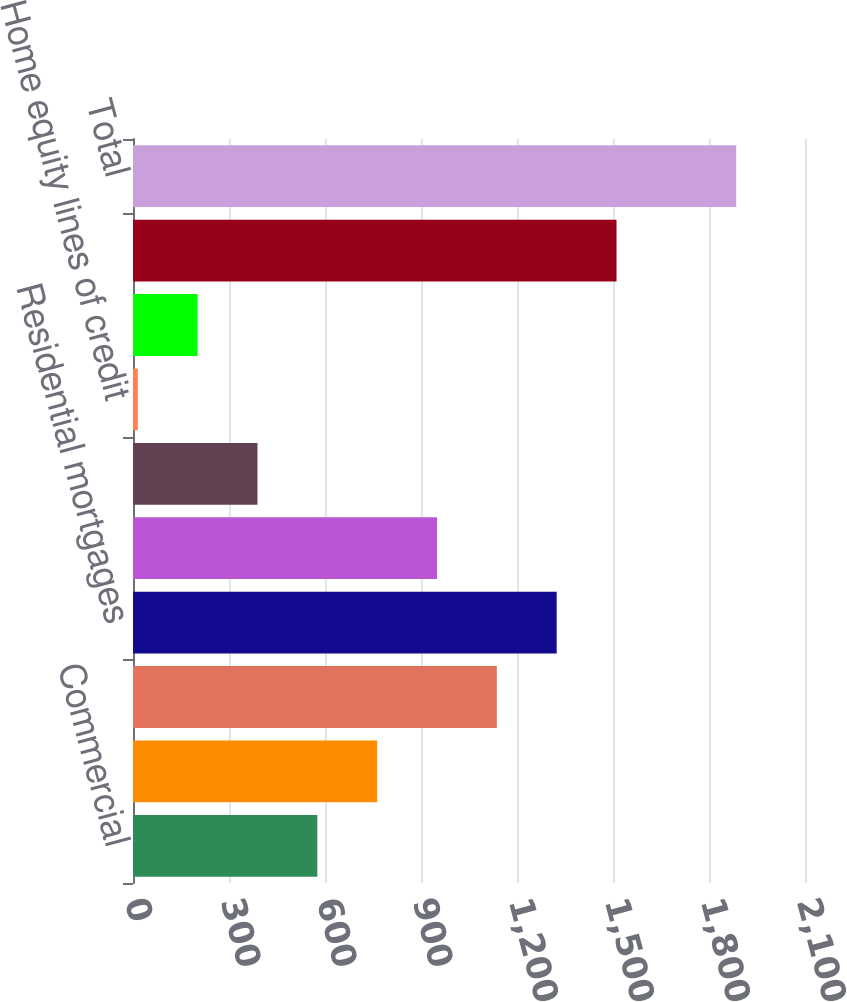Convert chart to OTSL. <chart><loc_0><loc_0><loc_500><loc_500><bar_chart><fcel>Commercial<fcel>Commercial real estate<fcel>Total commercial<fcel>Residential mortgages<fcel>Home equity loans<fcel>Home equity loans serviced by<fcel>Home equity lines of credit<fcel>Other retail<fcel>Total retail<fcel>Total<nl><fcel>576<fcel>763<fcel>1137<fcel>1324<fcel>950<fcel>389<fcel>15<fcel>202<fcel>1511<fcel>1885<nl></chart> 